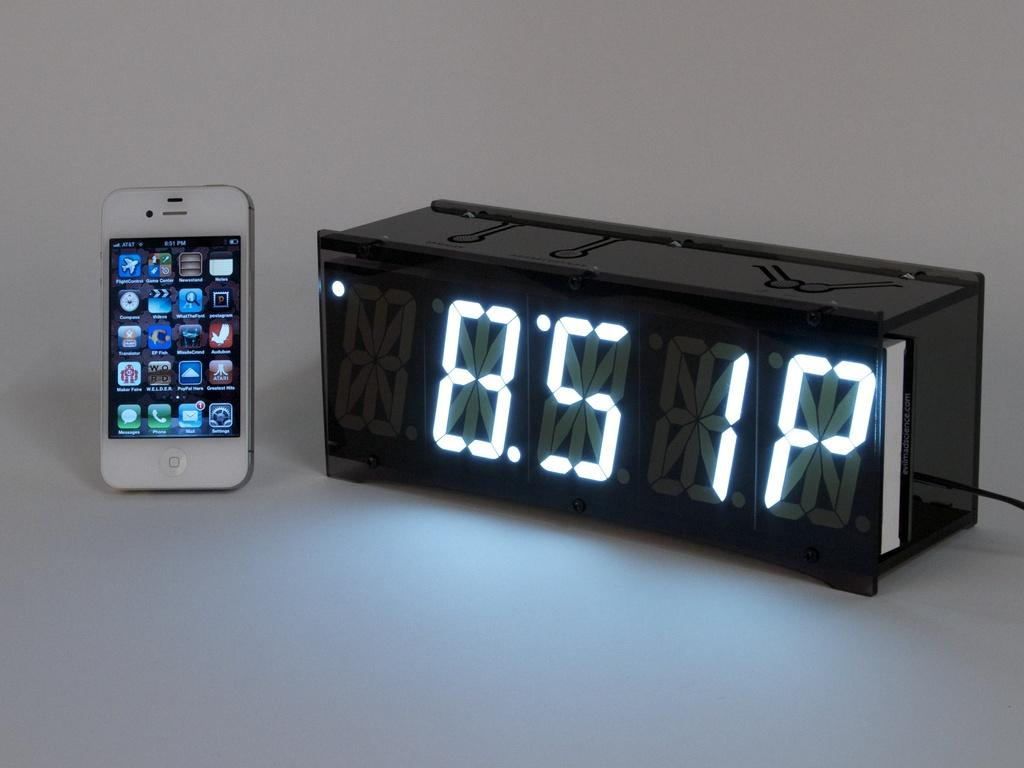<image>
Share a concise interpretation of the image provided. A cell phone is next to a clock displaying 8:51. 